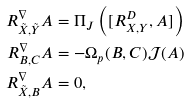<formula> <loc_0><loc_0><loc_500><loc_500>R ^ { \nabla } _ { \tilde { X } , \tilde { Y } } { A } & = \Pi _ { J } \left ( [ R ^ { D } _ { X , Y } , A ] \right ) \\ R ^ { \nabla } _ { B , C } { A } & = - \Omega _ { p } ( B , C ) { \mathcal { J } } ( A ) \\ R ^ { \nabla } _ { \tilde { X } , B } { A } & = 0 ,</formula> 